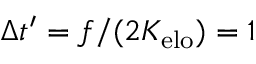Convert formula to latex. <formula><loc_0><loc_0><loc_500><loc_500>\Delta t ^ { \prime } = f / ( 2 K _ { e l o } ) = 1</formula> 